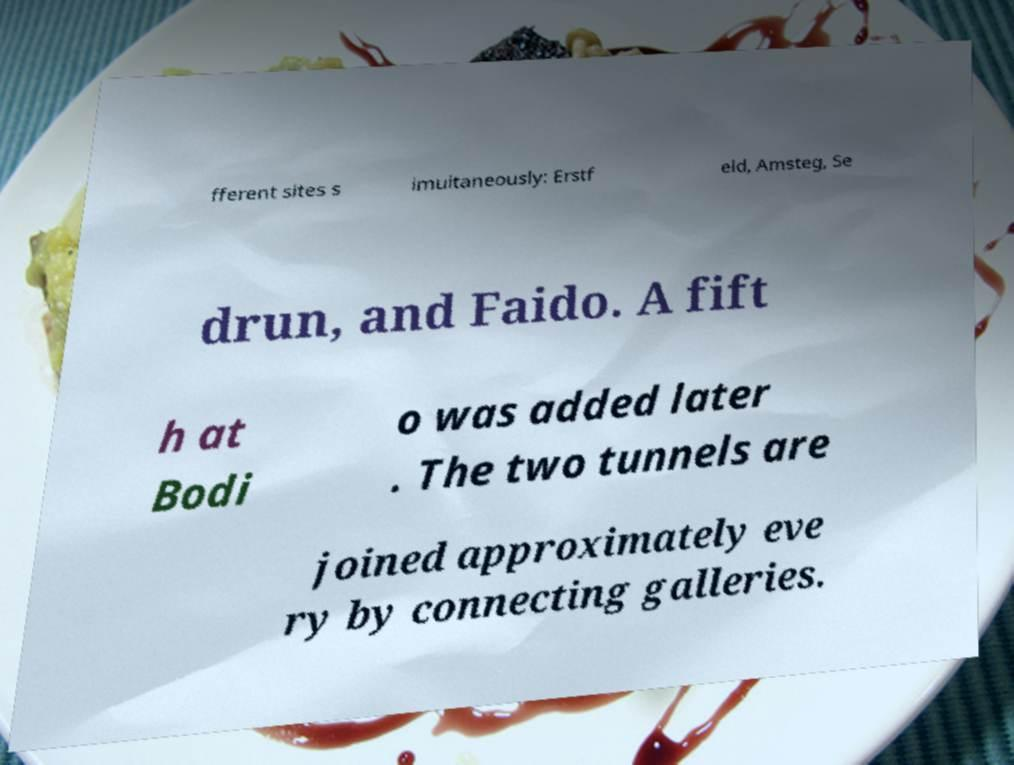For documentation purposes, I need the text within this image transcribed. Could you provide that? fferent sites s imultaneously: Erstf eld, Amsteg, Se drun, and Faido. A fift h at Bodi o was added later . The two tunnels are joined approximately eve ry by connecting galleries. 